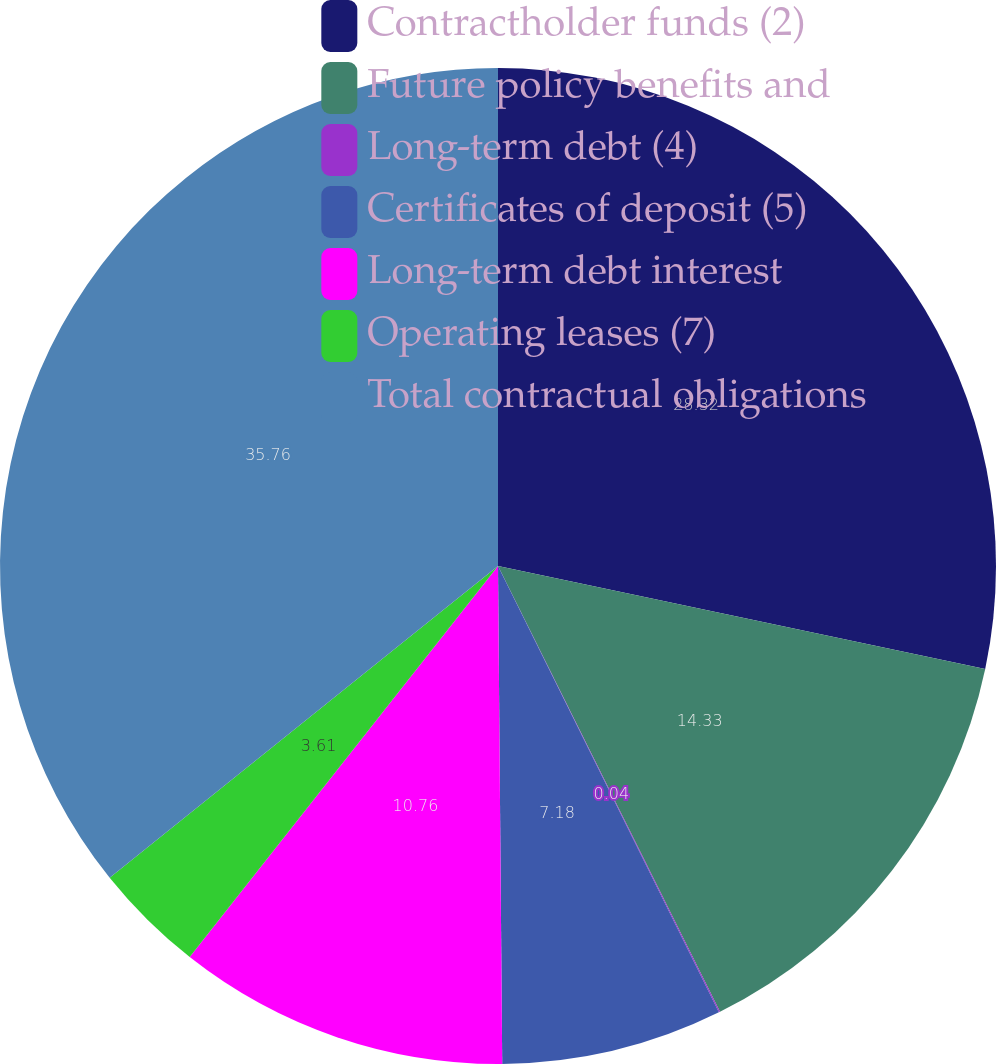Convert chart to OTSL. <chart><loc_0><loc_0><loc_500><loc_500><pie_chart><fcel>Contractholder funds (2)<fcel>Future policy benefits and<fcel>Long-term debt (4)<fcel>Certificates of deposit (5)<fcel>Long-term debt interest<fcel>Operating leases (7)<fcel>Total contractual obligations<nl><fcel>28.32%<fcel>14.33%<fcel>0.04%<fcel>7.18%<fcel>10.76%<fcel>3.61%<fcel>35.77%<nl></chart> 